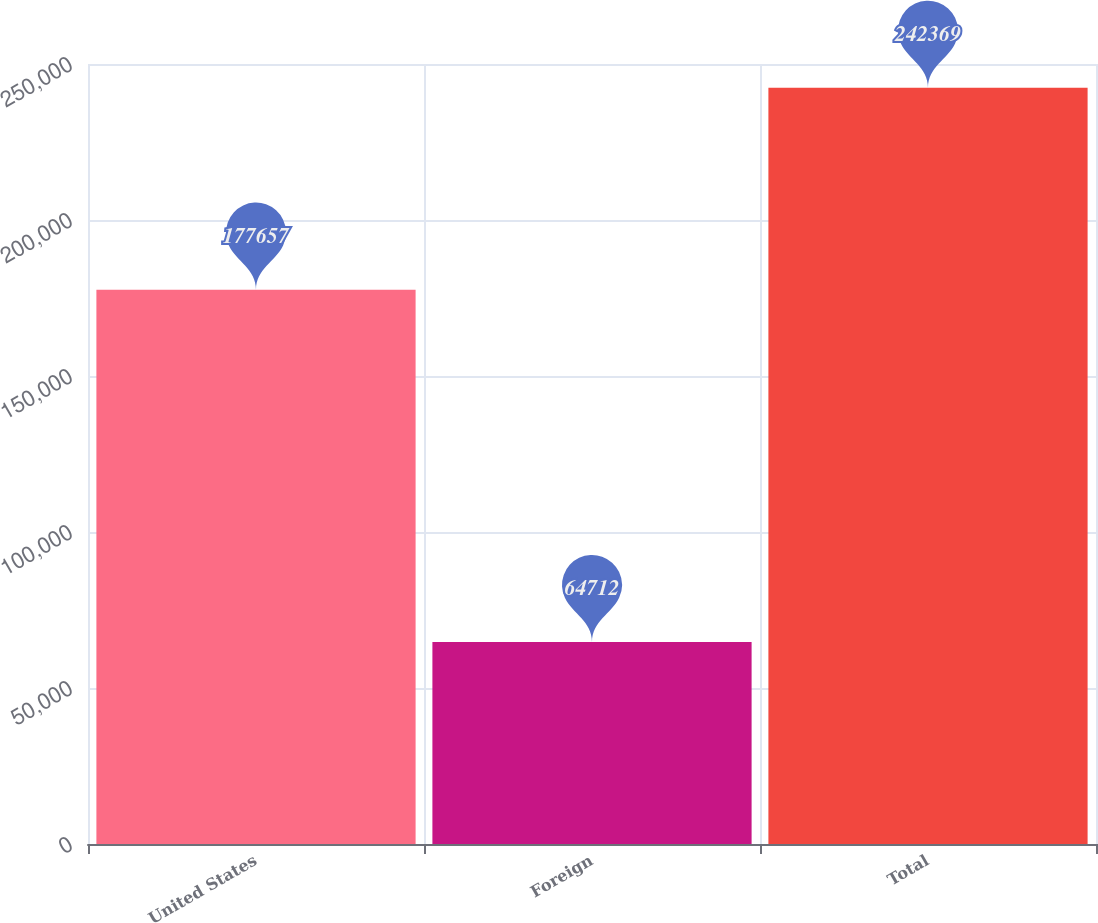Convert chart to OTSL. <chart><loc_0><loc_0><loc_500><loc_500><bar_chart><fcel>United States<fcel>Foreign<fcel>Total<nl><fcel>177657<fcel>64712<fcel>242369<nl></chart> 